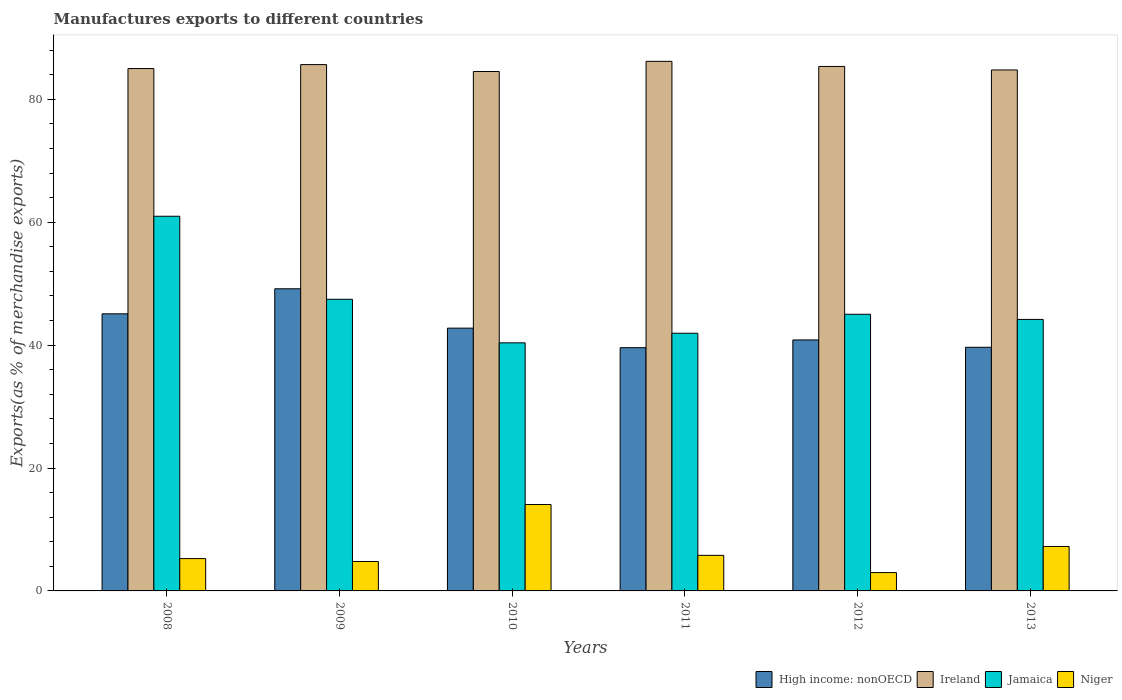How many different coloured bars are there?
Provide a short and direct response. 4. Are the number of bars per tick equal to the number of legend labels?
Give a very brief answer. Yes. Are the number of bars on each tick of the X-axis equal?
Your answer should be compact. Yes. How many bars are there on the 1st tick from the left?
Your answer should be very brief. 4. How many bars are there on the 5th tick from the right?
Your response must be concise. 4. What is the percentage of exports to different countries in Niger in 2012?
Offer a terse response. 2.98. Across all years, what is the maximum percentage of exports to different countries in High income: nonOECD?
Keep it short and to the point. 49.17. Across all years, what is the minimum percentage of exports to different countries in Jamaica?
Your response must be concise. 40.37. What is the total percentage of exports to different countries in High income: nonOECD in the graph?
Your answer should be compact. 257.08. What is the difference between the percentage of exports to different countries in Ireland in 2010 and that in 2013?
Make the answer very short. -0.25. What is the difference between the percentage of exports to different countries in High income: nonOECD in 2010 and the percentage of exports to different countries in Ireland in 2013?
Provide a short and direct response. -42.01. What is the average percentage of exports to different countries in Jamaica per year?
Make the answer very short. 46.65. In the year 2010, what is the difference between the percentage of exports to different countries in Ireland and percentage of exports to different countries in Jamaica?
Make the answer very short. 44.16. What is the ratio of the percentage of exports to different countries in Jamaica in 2011 to that in 2013?
Give a very brief answer. 0.95. Is the percentage of exports to different countries in Jamaica in 2008 less than that in 2009?
Your answer should be very brief. No. What is the difference between the highest and the second highest percentage of exports to different countries in Niger?
Your response must be concise. 6.83. What is the difference between the highest and the lowest percentage of exports to different countries in Niger?
Provide a succinct answer. 11.08. In how many years, is the percentage of exports to different countries in Niger greater than the average percentage of exports to different countries in Niger taken over all years?
Keep it short and to the point. 2. What does the 1st bar from the left in 2011 represents?
Make the answer very short. High income: nonOECD. What does the 3rd bar from the right in 2013 represents?
Your answer should be very brief. Ireland. How many bars are there?
Your answer should be very brief. 24. Are all the bars in the graph horizontal?
Your response must be concise. No. How many years are there in the graph?
Provide a short and direct response. 6. Are the values on the major ticks of Y-axis written in scientific E-notation?
Keep it short and to the point. No. Where does the legend appear in the graph?
Give a very brief answer. Bottom right. How many legend labels are there?
Give a very brief answer. 4. What is the title of the graph?
Your answer should be compact. Manufactures exports to different countries. What is the label or title of the Y-axis?
Provide a short and direct response. Exports(as % of merchandise exports). What is the Exports(as % of merchandise exports) in High income: nonOECD in 2008?
Your answer should be very brief. 45.09. What is the Exports(as % of merchandise exports) in Ireland in 2008?
Provide a short and direct response. 85. What is the Exports(as % of merchandise exports) in Jamaica in 2008?
Offer a very short reply. 60.97. What is the Exports(as % of merchandise exports) in Niger in 2008?
Your response must be concise. 5.26. What is the Exports(as % of merchandise exports) in High income: nonOECD in 2009?
Your response must be concise. 49.17. What is the Exports(as % of merchandise exports) of Ireland in 2009?
Provide a succinct answer. 85.64. What is the Exports(as % of merchandise exports) of Jamaica in 2009?
Ensure brevity in your answer.  47.46. What is the Exports(as % of merchandise exports) of Niger in 2009?
Your response must be concise. 4.79. What is the Exports(as % of merchandise exports) of High income: nonOECD in 2010?
Ensure brevity in your answer.  42.76. What is the Exports(as % of merchandise exports) of Ireland in 2010?
Your answer should be compact. 84.52. What is the Exports(as % of merchandise exports) of Jamaica in 2010?
Your answer should be very brief. 40.37. What is the Exports(as % of merchandise exports) in Niger in 2010?
Provide a short and direct response. 14.06. What is the Exports(as % of merchandise exports) of High income: nonOECD in 2011?
Offer a terse response. 39.58. What is the Exports(as % of merchandise exports) of Ireland in 2011?
Provide a short and direct response. 86.17. What is the Exports(as % of merchandise exports) of Jamaica in 2011?
Offer a very short reply. 41.93. What is the Exports(as % of merchandise exports) of Niger in 2011?
Make the answer very short. 5.79. What is the Exports(as % of merchandise exports) in High income: nonOECD in 2012?
Your answer should be very brief. 40.84. What is the Exports(as % of merchandise exports) in Ireland in 2012?
Offer a terse response. 85.34. What is the Exports(as % of merchandise exports) in Jamaica in 2012?
Offer a terse response. 45.02. What is the Exports(as % of merchandise exports) of Niger in 2012?
Make the answer very short. 2.98. What is the Exports(as % of merchandise exports) in High income: nonOECD in 2013?
Your response must be concise. 39.64. What is the Exports(as % of merchandise exports) in Ireland in 2013?
Your response must be concise. 84.77. What is the Exports(as % of merchandise exports) of Jamaica in 2013?
Keep it short and to the point. 44.18. What is the Exports(as % of merchandise exports) of Niger in 2013?
Keep it short and to the point. 7.23. Across all years, what is the maximum Exports(as % of merchandise exports) in High income: nonOECD?
Your answer should be compact. 49.17. Across all years, what is the maximum Exports(as % of merchandise exports) of Ireland?
Give a very brief answer. 86.17. Across all years, what is the maximum Exports(as % of merchandise exports) in Jamaica?
Keep it short and to the point. 60.97. Across all years, what is the maximum Exports(as % of merchandise exports) of Niger?
Provide a short and direct response. 14.06. Across all years, what is the minimum Exports(as % of merchandise exports) of High income: nonOECD?
Offer a very short reply. 39.58. Across all years, what is the minimum Exports(as % of merchandise exports) in Ireland?
Keep it short and to the point. 84.52. Across all years, what is the minimum Exports(as % of merchandise exports) in Jamaica?
Provide a short and direct response. 40.37. Across all years, what is the minimum Exports(as % of merchandise exports) of Niger?
Provide a succinct answer. 2.98. What is the total Exports(as % of merchandise exports) in High income: nonOECD in the graph?
Keep it short and to the point. 257.08. What is the total Exports(as % of merchandise exports) of Ireland in the graph?
Ensure brevity in your answer.  511.46. What is the total Exports(as % of merchandise exports) of Jamaica in the graph?
Give a very brief answer. 279.92. What is the total Exports(as % of merchandise exports) in Niger in the graph?
Your response must be concise. 40.11. What is the difference between the Exports(as % of merchandise exports) in High income: nonOECD in 2008 and that in 2009?
Your answer should be compact. -4.08. What is the difference between the Exports(as % of merchandise exports) in Ireland in 2008 and that in 2009?
Make the answer very short. -0.64. What is the difference between the Exports(as % of merchandise exports) of Jamaica in 2008 and that in 2009?
Your answer should be very brief. 13.51. What is the difference between the Exports(as % of merchandise exports) in Niger in 2008 and that in 2009?
Ensure brevity in your answer.  0.47. What is the difference between the Exports(as % of merchandise exports) in High income: nonOECD in 2008 and that in 2010?
Give a very brief answer. 2.33. What is the difference between the Exports(as % of merchandise exports) of Ireland in 2008 and that in 2010?
Provide a succinct answer. 0.48. What is the difference between the Exports(as % of merchandise exports) in Jamaica in 2008 and that in 2010?
Ensure brevity in your answer.  20.6. What is the difference between the Exports(as % of merchandise exports) in Niger in 2008 and that in 2010?
Your answer should be very brief. -8.8. What is the difference between the Exports(as % of merchandise exports) in High income: nonOECD in 2008 and that in 2011?
Ensure brevity in your answer.  5.51. What is the difference between the Exports(as % of merchandise exports) in Ireland in 2008 and that in 2011?
Give a very brief answer. -1.17. What is the difference between the Exports(as % of merchandise exports) of Jamaica in 2008 and that in 2011?
Your answer should be very brief. 19.03. What is the difference between the Exports(as % of merchandise exports) in Niger in 2008 and that in 2011?
Give a very brief answer. -0.53. What is the difference between the Exports(as % of merchandise exports) of High income: nonOECD in 2008 and that in 2012?
Ensure brevity in your answer.  4.25. What is the difference between the Exports(as % of merchandise exports) of Ireland in 2008 and that in 2012?
Give a very brief answer. -0.34. What is the difference between the Exports(as % of merchandise exports) in Jamaica in 2008 and that in 2012?
Your answer should be compact. 15.95. What is the difference between the Exports(as % of merchandise exports) in Niger in 2008 and that in 2012?
Your answer should be very brief. 2.28. What is the difference between the Exports(as % of merchandise exports) in High income: nonOECD in 2008 and that in 2013?
Give a very brief answer. 5.45. What is the difference between the Exports(as % of merchandise exports) of Ireland in 2008 and that in 2013?
Make the answer very short. 0.23. What is the difference between the Exports(as % of merchandise exports) of Jamaica in 2008 and that in 2013?
Offer a very short reply. 16.79. What is the difference between the Exports(as % of merchandise exports) of Niger in 2008 and that in 2013?
Provide a succinct answer. -1.97. What is the difference between the Exports(as % of merchandise exports) of High income: nonOECD in 2009 and that in 2010?
Make the answer very short. 6.41. What is the difference between the Exports(as % of merchandise exports) of Ireland in 2009 and that in 2010?
Ensure brevity in your answer.  1.12. What is the difference between the Exports(as % of merchandise exports) in Jamaica in 2009 and that in 2010?
Your answer should be very brief. 7.09. What is the difference between the Exports(as % of merchandise exports) in Niger in 2009 and that in 2010?
Give a very brief answer. -9.27. What is the difference between the Exports(as % of merchandise exports) of High income: nonOECD in 2009 and that in 2011?
Give a very brief answer. 9.59. What is the difference between the Exports(as % of merchandise exports) in Ireland in 2009 and that in 2011?
Make the answer very short. -0.53. What is the difference between the Exports(as % of merchandise exports) of Jamaica in 2009 and that in 2011?
Provide a succinct answer. 5.52. What is the difference between the Exports(as % of merchandise exports) of Niger in 2009 and that in 2011?
Your response must be concise. -1. What is the difference between the Exports(as % of merchandise exports) in High income: nonOECD in 2009 and that in 2012?
Provide a succinct answer. 8.33. What is the difference between the Exports(as % of merchandise exports) of Ireland in 2009 and that in 2012?
Provide a succinct answer. 0.3. What is the difference between the Exports(as % of merchandise exports) of Jamaica in 2009 and that in 2012?
Keep it short and to the point. 2.44. What is the difference between the Exports(as % of merchandise exports) in Niger in 2009 and that in 2012?
Provide a succinct answer. 1.81. What is the difference between the Exports(as % of merchandise exports) of High income: nonOECD in 2009 and that in 2013?
Offer a terse response. 9.52. What is the difference between the Exports(as % of merchandise exports) of Ireland in 2009 and that in 2013?
Your answer should be very brief. 0.87. What is the difference between the Exports(as % of merchandise exports) of Jamaica in 2009 and that in 2013?
Make the answer very short. 3.28. What is the difference between the Exports(as % of merchandise exports) in Niger in 2009 and that in 2013?
Make the answer very short. -2.44. What is the difference between the Exports(as % of merchandise exports) in High income: nonOECD in 2010 and that in 2011?
Give a very brief answer. 3.18. What is the difference between the Exports(as % of merchandise exports) in Ireland in 2010 and that in 2011?
Your answer should be compact. -1.65. What is the difference between the Exports(as % of merchandise exports) of Jamaica in 2010 and that in 2011?
Your answer should be compact. -1.57. What is the difference between the Exports(as % of merchandise exports) of Niger in 2010 and that in 2011?
Keep it short and to the point. 8.27. What is the difference between the Exports(as % of merchandise exports) of High income: nonOECD in 2010 and that in 2012?
Provide a short and direct response. 1.92. What is the difference between the Exports(as % of merchandise exports) of Ireland in 2010 and that in 2012?
Ensure brevity in your answer.  -0.82. What is the difference between the Exports(as % of merchandise exports) in Jamaica in 2010 and that in 2012?
Give a very brief answer. -4.65. What is the difference between the Exports(as % of merchandise exports) in Niger in 2010 and that in 2012?
Give a very brief answer. 11.08. What is the difference between the Exports(as % of merchandise exports) of High income: nonOECD in 2010 and that in 2013?
Provide a succinct answer. 3.12. What is the difference between the Exports(as % of merchandise exports) of Ireland in 2010 and that in 2013?
Your answer should be compact. -0.25. What is the difference between the Exports(as % of merchandise exports) of Jamaica in 2010 and that in 2013?
Give a very brief answer. -3.81. What is the difference between the Exports(as % of merchandise exports) of Niger in 2010 and that in 2013?
Your answer should be very brief. 6.83. What is the difference between the Exports(as % of merchandise exports) in High income: nonOECD in 2011 and that in 2012?
Make the answer very short. -1.26. What is the difference between the Exports(as % of merchandise exports) in Ireland in 2011 and that in 2012?
Your answer should be compact. 0.83. What is the difference between the Exports(as % of merchandise exports) in Jamaica in 2011 and that in 2012?
Your response must be concise. -3.08. What is the difference between the Exports(as % of merchandise exports) in Niger in 2011 and that in 2012?
Offer a very short reply. 2.81. What is the difference between the Exports(as % of merchandise exports) of High income: nonOECD in 2011 and that in 2013?
Ensure brevity in your answer.  -0.06. What is the difference between the Exports(as % of merchandise exports) in Ireland in 2011 and that in 2013?
Give a very brief answer. 1.4. What is the difference between the Exports(as % of merchandise exports) of Jamaica in 2011 and that in 2013?
Your answer should be very brief. -2.25. What is the difference between the Exports(as % of merchandise exports) of Niger in 2011 and that in 2013?
Offer a terse response. -1.44. What is the difference between the Exports(as % of merchandise exports) of High income: nonOECD in 2012 and that in 2013?
Your answer should be compact. 1.19. What is the difference between the Exports(as % of merchandise exports) of Ireland in 2012 and that in 2013?
Provide a succinct answer. 0.57. What is the difference between the Exports(as % of merchandise exports) in Jamaica in 2012 and that in 2013?
Provide a short and direct response. 0.84. What is the difference between the Exports(as % of merchandise exports) of Niger in 2012 and that in 2013?
Provide a succinct answer. -4.25. What is the difference between the Exports(as % of merchandise exports) in High income: nonOECD in 2008 and the Exports(as % of merchandise exports) in Ireland in 2009?
Provide a succinct answer. -40.55. What is the difference between the Exports(as % of merchandise exports) in High income: nonOECD in 2008 and the Exports(as % of merchandise exports) in Jamaica in 2009?
Offer a terse response. -2.37. What is the difference between the Exports(as % of merchandise exports) of High income: nonOECD in 2008 and the Exports(as % of merchandise exports) of Niger in 2009?
Provide a succinct answer. 40.3. What is the difference between the Exports(as % of merchandise exports) in Ireland in 2008 and the Exports(as % of merchandise exports) in Jamaica in 2009?
Keep it short and to the point. 37.54. What is the difference between the Exports(as % of merchandise exports) in Ireland in 2008 and the Exports(as % of merchandise exports) in Niger in 2009?
Offer a terse response. 80.21. What is the difference between the Exports(as % of merchandise exports) in Jamaica in 2008 and the Exports(as % of merchandise exports) in Niger in 2009?
Offer a terse response. 56.18. What is the difference between the Exports(as % of merchandise exports) in High income: nonOECD in 2008 and the Exports(as % of merchandise exports) in Ireland in 2010?
Ensure brevity in your answer.  -39.43. What is the difference between the Exports(as % of merchandise exports) of High income: nonOECD in 2008 and the Exports(as % of merchandise exports) of Jamaica in 2010?
Your response must be concise. 4.72. What is the difference between the Exports(as % of merchandise exports) of High income: nonOECD in 2008 and the Exports(as % of merchandise exports) of Niger in 2010?
Provide a short and direct response. 31.03. What is the difference between the Exports(as % of merchandise exports) in Ireland in 2008 and the Exports(as % of merchandise exports) in Jamaica in 2010?
Offer a very short reply. 44.63. What is the difference between the Exports(as % of merchandise exports) in Ireland in 2008 and the Exports(as % of merchandise exports) in Niger in 2010?
Provide a short and direct response. 70.94. What is the difference between the Exports(as % of merchandise exports) of Jamaica in 2008 and the Exports(as % of merchandise exports) of Niger in 2010?
Give a very brief answer. 46.91. What is the difference between the Exports(as % of merchandise exports) in High income: nonOECD in 2008 and the Exports(as % of merchandise exports) in Ireland in 2011?
Offer a terse response. -41.08. What is the difference between the Exports(as % of merchandise exports) in High income: nonOECD in 2008 and the Exports(as % of merchandise exports) in Jamaica in 2011?
Your answer should be compact. 3.16. What is the difference between the Exports(as % of merchandise exports) of High income: nonOECD in 2008 and the Exports(as % of merchandise exports) of Niger in 2011?
Offer a terse response. 39.3. What is the difference between the Exports(as % of merchandise exports) of Ireland in 2008 and the Exports(as % of merchandise exports) of Jamaica in 2011?
Provide a succinct answer. 43.07. What is the difference between the Exports(as % of merchandise exports) in Ireland in 2008 and the Exports(as % of merchandise exports) in Niger in 2011?
Make the answer very short. 79.21. What is the difference between the Exports(as % of merchandise exports) in Jamaica in 2008 and the Exports(as % of merchandise exports) in Niger in 2011?
Offer a very short reply. 55.18. What is the difference between the Exports(as % of merchandise exports) in High income: nonOECD in 2008 and the Exports(as % of merchandise exports) in Ireland in 2012?
Ensure brevity in your answer.  -40.25. What is the difference between the Exports(as % of merchandise exports) in High income: nonOECD in 2008 and the Exports(as % of merchandise exports) in Jamaica in 2012?
Ensure brevity in your answer.  0.07. What is the difference between the Exports(as % of merchandise exports) in High income: nonOECD in 2008 and the Exports(as % of merchandise exports) in Niger in 2012?
Your response must be concise. 42.11. What is the difference between the Exports(as % of merchandise exports) in Ireland in 2008 and the Exports(as % of merchandise exports) in Jamaica in 2012?
Provide a succinct answer. 39.98. What is the difference between the Exports(as % of merchandise exports) in Ireland in 2008 and the Exports(as % of merchandise exports) in Niger in 2012?
Your answer should be very brief. 82.02. What is the difference between the Exports(as % of merchandise exports) of Jamaica in 2008 and the Exports(as % of merchandise exports) of Niger in 2012?
Offer a terse response. 57.98. What is the difference between the Exports(as % of merchandise exports) in High income: nonOECD in 2008 and the Exports(as % of merchandise exports) in Ireland in 2013?
Ensure brevity in your answer.  -39.68. What is the difference between the Exports(as % of merchandise exports) of High income: nonOECD in 2008 and the Exports(as % of merchandise exports) of Jamaica in 2013?
Give a very brief answer. 0.91. What is the difference between the Exports(as % of merchandise exports) of High income: nonOECD in 2008 and the Exports(as % of merchandise exports) of Niger in 2013?
Give a very brief answer. 37.86. What is the difference between the Exports(as % of merchandise exports) in Ireland in 2008 and the Exports(as % of merchandise exports) in Jamaica in 2013?
Your answer should be very brief. 40.82. What is the difference between the Exports(as % of merchandise exports) in Ireland in 2008 and the Exports(as % of merchandise exports) in Niger in 2013?
Make the answer very short. 77.77. What is the difference between the Exports(as % of merchandise exports) of Jamaica in 2008 and the Exports(as % of merchandise exports) of Niger in 2013?
Offer a very short reply. 53.74. What is the difference between the Exports(as % of merchandise exports) in High income: nonOECD in 2009 and the Exports(as % of merchandise exports) in Ireland in 2010?
Ensure brevity in your answer.  -35.36. What is the difference between the Exports(as % of merchandise exports) of High income: nonOECD in 2009 and the Exports(as % of merchandise exports) of Jamaica in 2010?
Ensure brevity in your answer.  8.8. What is the difference between the Exports(as % of merchandise exports) of High income: nonOECD in 2009 and the Exports(as % of merchandise exports) of Niger in 2010?
Provide a succinct answer. 35.11. What is the difference between the Exports(as % of merchandise exports) in Ireland in 2009 and the Exports(as % of merchandise exports) in Jamaica in 2010?
Offer a terse response. 45.28. What is the difference between the Exports(as % of merchandise exports) of Ireland in 2009 and the Exports(as % of merchandise exports) of Niger in 2010?
Offer a terse response. 71.58. What is the difference between the Exports(as % of merchandise exports) in Jamaica in 2009 and the Exports(as % of merchandise exports) in Niger in 2010?
Provide a succinct answer. 33.4. What is the difference between the Exports(as % of merchandise exports) in High income: nonOECD in 2009 and the Exports(as % of merchandise exports) in Ireland in 2011?
Provide a succinct answer. -37.01. What is the difference between the Exports(as % of merchandise exports) in High income: nonOECD in 2009 and the Exports(as % of merchandise exports) in Jamaica in 2011?
Ensure brevity in your answer.  7.23. What is the difference between the Exports(as % of merchandise exports) in High income: nonOECD in 2009 and the Exports(as % of merchandise exports) in Niger in 2011?
Give a very brief answer. 43.38. What is the difference between the Exports(as % of merchandise exports) in Ireland in 2009 and the Exports(as % of merchandise exports) in Jamaica in 2011?
Make the answer very short. 43.71. What is the difference between the Exports(as % of merchandise exports) in Ireland in 2009 and the Exports(as % of merchandise exports) in Niger in 2011?
Offer a terse response. 79.86. What is the difference between the Exports(as % of merchandise exports) in Jamaica in 2009 and the Exports(as % of merchandise exports) in Niger in 2011?
Ensure brevity in your answer.  41.67. What is the difference between the Exports(as % of merchandise exports) of High income: nonOECD in 2009 and the Exports(as % of merchandise exports) of Ireland in 2012?
Offer a very short reply. -36.18. What is the difference between the Exports(as % of merchandise exports) in High income: nonOECD in 2009 and the Exports(as % of merchandise exports) in Jamaica in 2012?
Ensure brevity in your answer.  4.15. What is the difference between the Exports(as % of merchandise exports) in High income: nonOECD in 2009 and the Exports(as % of merchandise exports) in Niger in 2012?
Your response must be concise. 46.18. What is the difference between the Exports(as % of merchandise exports) of Ireland in 2009 and the Exports(as % of merchandise exports) of Jamaica in 2012?
Offer a very short reply. 40.63. What is the difference between the Exports(as % of merchandise exports) in Ireland in 2009 and the Exports(as % of merchandise exports) in Niger in 2012?
Your response must be concise. 82.66. What is the difference between the Exports(as % of merchandise exports) of Jamaica in 2009 and the Exports(as % of merchandise exports) of Niger in 2012?
Give a very brief answer. 44.48. What is the difference between the Exports(as % of merchandise exports) of High income: nonOECD in 2009 and the Exports(as % of merchandise exports) of Ireland in 2013?
Provide a succinct answer. -35.61. What is the difference between the Exports(as % of merchandise exports) in High income: nonOECD in 2009 and the Exports(as % of merchandise exports) in Jamaica in 2013?
Offer a terse response. 4.99. What is the difference between the Exports(as % of merchandise exports) of High income: nonOECD in 2009 and the Exports(as % of merchandise exports) of Niger in 2013?
Make the answer very short. 41.94. What is the difference between the Exports(as % of merchandise exports) in Ireland in 2009 and the Exports(as % of merchandise exports) in Jamaica in 2013?
Ensure brevity in your answer.  41.46. What is the difference between the Exports(as % of merchandise exports) in Ireland in 2009 and the Exports(as % of merchandise exports) in Niger in 2013?
Provide a succinct answer. 78.41. What is the difference between the Exports(as % of merchandise exports) of Jamaica in 2009 and the Exports(as % of merchandise exports) of Niger in 2013?
Give a very brief answer. 40.23. What is the difference between the Exports(as % of merchandise exports) of High income: nonOECD in 2010 and the Exports(as % of merchandise exports) of Ireland in 2011?
Offer a very short reply. -43.41. What is the difference between the Exports(as % of merchandise exports) in High income: nonOECD in 2010 and the Exports(as % of merchandise exports) in Jamaica in 2011?
Offer a very short reply. 0.83. What is the difference between the Exports(as % of merchandise exports) of High income: nonOECD in 2010 and the Exports(as % of merchandise exports) of Niger in 2011?
Provide a succinct answer. 36.97. What is the difference between the Exports(as % of merchandise exports) of Ireland in 2010 and the Exports(as % of merchandise exports) of Jamaica in 2011?
Your response must be concise. 42.59. What is the difference between the Exports(as % of merchandise exports) of Ireland in 2010 and the Exports(as % of merchandise exports) of Niger in 2011?
Ensure brevity in your answer.  78.73. What is the difference between the Exports(as % of merchandise exports) of Jamaica in 2010 and the Exports(as % of merchandise exports) of Niger in 2011?
Make the answer very short. 34.58. What is the difference between the Exports(as % of merchandise exports) in High income: nonOECD in 2010 and the Exports(as % of merchandise exports) in Ireland in 2012?
Offer a terse response. -42.58. What is the difference between the Exports(as % of merchandise exports) of High income: nonOECD in 2010 and the Exports(as % of merchandise exports) of Jamaica in 2012?
Ensure brevity in your answer.  -2.26. What is the difference between the Exports(as % of merchandise exports) in High income: nonOECD in 2010 and the Exports(as % of merchandise exports) in Niger in 2012?
Keep it short and to the point. 39.78. What is the difference between the Exports(as % of merchandise exports) of Ireland in 2010 and the Exports(as % of merchandise exports) of Jamaica in 2012?
Your answer should be very brief. 39.51. What is the difference between the Exports(as % of merchandise exports) of Ireland in 2010 and the Exports(as % of merchandise exports) of Niger in 2012?
Provide a short and direct response. 81.54. What is the difference between the Exports(as % of merchandise exports) in Jamaica in 2010 and the Exports(as % of merchandise exports) in Niger in 2012?
Your answer should be compact. 37.38. What is the difference between the Exports(as % of merchandise exports) of High income: nonOECD in 2010 and the Exports(as % of merchandise exports) of Ireland in 2013?
Your answer should be very brief. -42.01. What is the difference between the Exports(as % of merchandise exports) in High income: nonOECD in 2010 and the Exports(as % of merchandise exports) in Jamaica in 2013?
Give a very brief answer. -1.42. What is the difference between the Exports(as % of merchandise exports) of High income: nonOECD in 2010 and the Exports(as % of merchandise exports) of Niger in 2013?
Give a very brief answer. 35.53. What is the difference between the Exports(as % of merchandise exports) of Ireland in 2010 and the Exports(as % of merchandise exports) of Jamaica in 2013?
Offer a very short reply. 40.34. What is the difference between the Exports(as % of merchandise exports) in Ireland in 2010 and the Exports(as % of merchandise exports) in Niger in 2013?
Ensure brevity in your answer.  77.29. What is the difference between the Exports(as % of merchandise exports) in Jamaica in 2010 and the Exports(as % of merchandise exports) in Niger in 2013?
Make the answer very short. 33.14. What is the difference between the Exports(as % of merchandise exports) in High income: nonOECD in 2011 and the Exports(as % of merchandise exports) in Ireland in 2012?
Your answer should be compact. -45.76. What is the difference between the Exports(as % of merchandise exports) in High income: nonOECD in 2011 and the Exports(as % of merchandise exports) in Jamaica in 2012?
Offer a very short reply. -5.44. What is the difference between the Exports(as % of merchandise exports) in High income: nonOECD in 2011 and the Exports(as % of merchandise exports) in Niger in 2012?
Provide a succinct answer. 36.6. What is the difference between the Exports(as % of merchandise exports) of Ireland in 2011 and the Exports(as % of merchandise exports) of Jamaica in 2012?
Provide a short and direct response. 41.15. What is the difference between the Exports(as % of merchandise exports) of Ireland in 2011 and the Exports(as % of merchandise exports) of Niger in 2012?
Provide a succinct answer. 83.19. What is the difference between the Exports(as % of merchandise exports) in Jamaica in 2011 and the Exports(as % of merchandise exports) in Niger in 2012?
Ensure brevity in your answer.  38.95. What is the difference between the Exports(as % of merchandise exports) of High income: nonOECD in 2011 and the Exports(as % of merchandise exports) of Ireland in 2013?
Offer a very short reply. -45.19. What is the difference between the Exports(as % of merchandise exports) in High income: nonOECD in 2011 and the Exports(as % of merchandise exports) in Jamaica in 2013?
Offer a terse response. -4.6. What is the difference between the Exports(as % of merchandise exports) in High income: nonOECD in 2011 and the Exports(as % of merchandise exports) in Niger in 2013?
Provide a succinct answer. 32.35. What is the difference between the Exports(as % of merchandise exports) of Ireland in 2011 and the Exports(as % of merchandise exports) of Jamaica in 2013?
Provide a succinct answer. 41.99. What is the difference between the Exports(as % of merchandise exports) of Ireland in 2011 and the Exports(as % of merchandise exports) of Niger in 2013?
Your answer should be very brief. 78.94. What is the difference between the Exports(as % of merchandise exports) of Jamaica in 2011 and the Exports(as % of merchandise exports) of Niger in 2013?
Offer a terse response. 34.7. What is the difference between the Exports(as % of merchandise exports) in High income: nonOECD in 2012 and the Exports(as % of merchandise exports) in Ireland in 2013?
Provide a succinct answer. -43.94. What is the difference between the Exports(as % of merchandise exports) of High income: nonOECD in 2012 and the Exports(as % of merchandise exports) of Jamaica in 2013?
Provide a succinct answer. -3.34. What is the difference between the Exports(as % of merchandise exports) in High income: nonOECD in 2012 and the Exports(as % of merchandise exports) in Niger in 2013?
Your answer should be compact. 33.61. What is the difference between the Exports(as % of merchandise exports) of Ireland in 2012 and the Exports(as % of merchandise exports) of Jamaica in 2013?
Offer a very short reply. 41.17. What is the difference between the Exports(as % of merchandise exports) in Ireland in 2012 and the Exports(as % of merchandise exports) in Niger in 2013?
Ensure brevity in your answer.  78.11. What is the difference between the Exports(as % of merchandise exports) in Jamaica in 2012 and the Exports(as % of merchandise exports) in Niger in 2013?
Offer a very short reply. 37.79. What is the average Exports(as % of merchandise exports) in High income: nonOECD per year?
Offer a very short reply. 42.85. What is the average Exports(as % of merchandise exports) of Ireland per year?
Offer a terse response. 85.24. What is the average Exports(as % of merchandise exports) in Jamaica per year?
Keep it short and to the point. 46.65. What is the average Exports(as % of merchandise exports) of Niger per year?
Make the answer very short. 6.69. In the year 2008, what is the difference between the Exports(as % of merchandise exports) in High income: nonOECD and Exports(as % of merchandise exports) in Ireland?
Offer a terse response. -39.91. In the year 2008, what is the difference between the Exports(as % of merchandise exports) of High income: nonOECD and Exports(as % of merchandise exports) of Jamaica?
Offer a terse response. -15.88. In the year 2008, what is the difference between the Exports(as % of merchandise exports) in High income: nonOECD and Exports(as % of merchandise exports) in Niger?
Offer a very short reply. 39.83. In the year 2008, what is the difference between the Exports(as % of merchandise exports) in Ireland and Exports(as % of merchandise exports) in Jamaica?
Your response must be concise. 24.03. In the year 2008, what is the difference between the Exports(as % of merchandise exports) of Ireland and Exports(as % of merchandise exports) of Niger?
Provide a short and direct response. 79.74. In the year 2008, what is the difference between the Exports(as % of merchandise exports) in Jamaica and Exports(as % of merchandise exports) in Niger?
Offer a terse response. 55.7. In the year 2009, what is the difference between the Exports(as % of merchandise exports) of High income: nonOECD and Exports(as % of merchandise exports) of Ireland?
Make the answer very short. -36.48. In the year 2009, what is the difference between the Exports(as % of merchandise exports) of High income: nonOECD and Exports(as % of merchandise exports) of Jamaica?
Your answer should be compact. 1.71. In the year 2009, what is the difference between the Exports(as % of merchandise exports) of High income: nonOECD and Exports(as % of merchandise exports) of Niger?
Make the answer very short. 44.38. In the year 2009, what is the difference between the Exports(as % of merchandise exports) in Ireland and Exports(as % of merchandise exports) in Jamaica?
Make the answer very short. 38.19. In the year 2009, what is the difference between the Exports(as % of merchandise exports) of Ireland and Exports(as % of merchandise exports) of Niger?
Make the answer very short. 80.85. In the year 2009, what is the difference between the Exports(as % of merchandise exports) in Jamaica and Exports(as % of merchandise exports) in Niger?
Provide a succinct answer. 42.67. In the year 2010, what is the difference between the Exports(as % of merchandise exports) of High income: nonOECD and Exports(as % of merchandise exports) of Ireland?
Make the answer very short. -41.76. In the year 2010, what is the difference between the Exports(as % of merchandise exports) in High income: nonOECD and Exports(as % of merchandise exports) in Jamaica?
Make the answer very short. 2.39. In the year 2010, what is the difference between the Exports(as % of merchandise exports) of High income: nonOECD and Exports(as % of merchandise exports) of Niger?
Offer a terse response. 28.7. In the year 2010, what is the difference between the Exports(as % of merchandise exports) in Ireland and Exports(as % of merchandise exports) in Jamaica?
Provide a succinct answer. 44.16. In the year 2010, what is the difference between the Exports(as % of merchandise exports) of Ireland and Exports(as % of merchandise exports) of Niger?
Keep it short and to the point. 70.46. In the year 2010, what is the difference between the Exports(as % of merchandise exports) of Jamaica and Exports(as % of merchandise exports) of Niger?
Offer a very short reply. 26.31. In the year 2011, what is the difference between the Exports(as % of merchandise exports) in High income: nonOECD and Exports(as % of merchandise exports) in Ireland?
Provide a short and direct response. -46.59. In the year 2011, what is the difference between the Exports(as % of merchandise exports) in High income: nonOECD and Exports(as % of merchandise exports) in Jamaica?
Your response must be concise. -2.35. In the year 2011, what is the difference between the Exports(as % of merchandise exports) of High income: nonOECD and Exports(as % of merchandise exports) of Niger?
Offer a very short reply. 33.79. In the year 2011, what is the difference between the Exports(as % of merchandise exports) of Ireland and Exports(as % of merchandise exports) of Jamaica?
Offer a very short reply. 44.24. In the year 2011, what is the difference between the Exports(as % of merchandise exports) in Ireland and Exports(as % of merchandise exports) in Niger?
Your answer should be very brief. 80.38. In the year 2011, what is the difference between the Exports(as % of merchandise exports) of Jamaica and Exports(as % of merchandise exports) of Niger?
Make the answer very short. 36.15. In the year 2012, what is the difference between the Exports(as % of merchandise exports) of High income: nonOECD and Exports(as % of merchandise exports) of Ireland?
Give a very brief answer. -44.51. In the year 2012, what is the difference between the Exports(as % of merchandise exports) in High income: nonOECD and Exports(as % of merchandise exports) in Jamaica?
Provide a succinct answer. -4.18. In the year 2012, what is the difference between the Exports(as % of merchandise exports) in High income: nonOECD and Exports(as % of merchandise exports) in Niger?
Provide a short and direct response. 37.86. In the year 2012, what is the difference between the Exports(as % of merchandise exports) of Ireland and Exports(as % of merchandise exports) of Jamaica?
Offer a terse response. 40.33. In the year 2012, what is the difference between the Exports(as % of merchandise exports) in Ireland and Exports(as % of merchandise exports) in Niger?
Your answer should be compact. 82.36. In the year 2012, what is the difference between the Exports(as % of merchandise exports) of Jamaica and Exports(as % of merchandise exports) of Niger?
Ensure brevity in your answer.  42.03. In the year 2013, what is the difference between the Exports(as % of merchandise exports) in High income: nonOECD and Exports(as % of merchandise exports) in Ireland?
Offer a very short reply. -45.13. In the year 2013, what is the difference between the Exports(as % of merchandise exports) of High income: nonOECD and Exports(as % of merchandise exports) of Jamaica?
Your answer should be very brief. -4.54. In the year 2013, what is the difference between the Exports(as % of merchandise exports) in High income: nonOECD and Exports(as % of merchandise exports) in Niger?
Offer a very short reply. 32.41. In the year 2013, what is the difference between the Exports(as % of merchandise exports) in Ireland and Exports(as % of merchandise exports) in Jamaica?
Provide a short and direct response. 40.6. In the year 2013, what is the difference between the Exports(as % of merchandise exports) of Ireland and Exports(as % of merchandise exports) of Niger?
Keep it short and to the point. 77.54. In the year 2013, what is the difference between the Exports(as % of merchandise exports) of Jamaica and Exports(as % of merchandise exports) of Niger?
Your answer should be very brief. 36.95. What is the ratio of the Exports(as % of merchandise exports) in High income: nonOECD in 2008 to that in 2009?
Provide a succinct answer. 0.92. What is the ratio of the Exports(as % of merchandise exports) in Ireland in 2008 to that in 2009?
Your answer should be very brief. 0.99. What is the ratio of the Exports(as % of merchandise exports) of Jamaica in 2008 to that in 2009?
Provide a short and direct response. 1.28. What is the ratio of the Exports(as % of merchandise exports) in Niger in 2008 to that in 2009?
Your answer should be compact. 1.1. What is the ratio of the Exports(as % of merchandise exports) of High income: nonOECD in 2008 to that in 2010?
Ensure brevity in your answer.  1.05. What is the ratio of the Exports(as % of merchandise exports) of Ireland in 2008 to that in 2010?
Offer a terse response. 1.01. What is the ratio of the Exports(as % of merchandise exports) of Jamaica in 2008 to that in 2010?
Make the answer very short. 1.51. What is the ratio of the Exports(as % of merchandise exports) in Niger in 2008 to that in 2010?
Ensure brevity in your answer.  0.37. What is the ratio of the Exports(as % of merchandise exports) in High income: nonOECD in 2008 to that in 2011?
Your answer should be compact. 1.14. What is the ratio of the Exports(as % of merchandise exports) in Ireland in 2008 to that in 2011?
Provide a succinct answer. 0.99. What is the ratio of the Exports(as % of merchandise exports) in Jamaica in 2008 to that in 2011?
Provide a succinct answer. 1.45. What is the ratio of the Exports(as % of merchandise exports) of Niger in 2008 to that in 2011?
Offer a very short reply. 0.91. What is the ratio of the Exports(as % of merchandise exports) of High income: nonOECD in 2008 to that in 2012?
Keep it short and to the point. 1.1. What is the ratio of the Exports(as % of merchandise exports) of Jamaica in 2008 to that in 2012?
Your response must be concise. 1.35. What is the ratio of the Exports(as % of merchandise exports) in Niger in 2008 to that in 2012?
Provide a short and direct response. 1.76. What is the ratio of the Exports(as % of merchandise exports) in High income: nonOECD in 2008 to that in 2013?
Your response must be concise. 1.14. What is the ratio of the Exports(as % of merchandise exports) in Ireland in 2008 to that in 2013?
Your response must be concise. 1. What is the ratio of the Exports(as % of merchandise exports) of Jamaica in 2008 to that in 2013?
Give a very brief answer. 1.38. What is the ratio of the Exports(as % of merchandise exports) in Niger in 2008 to that in 2013?
Ensure brevity in your answer.  0.73. What is the ratio of the Exports(as % of merchandise exports) of High income: nonOECD in 2009 to that in 2010?
Offer a terse response. 1.15. What is the ratio of the Exports(as % of merchandise exports) in Ireland in 2009 to that in 2010?
Make the answer very short. 1.01. What is the ratio of the Exports(as % of merchandise exports) in Jamaica in 2009 to that in 2010?
Ensure brevity in your answer.  1.18. What is the ratio of the Exports(as % of merchandise exports) of Niger in 2009 to that in 2010?
Make the answer very short. 0.34. What is the ratio of the Exports(as % of merchandise exports) in High income: nonOECD in 2009 to that in 2011?
Keep it short and to the point. 1.24. What is the ratio of the Exports(as % of merchandise exports) of Jamaica in 2009 to that in 2011?
Keep it short and to the point. 1.13. What is the ratio of the Exports(as % of merchandise exports) in Niger in 2009 to that in 2011?
Offer a terse response. 0.83. What is the ratio of the Exports(as % of merchandise exports) of High income: nonOECD in 2009 to that in 2012?
Offer a terse response. 1.2. What is the ratio of the Exports(as % of merchandise exports) in Ireland in 2009 to that in 2012?
Provide a succinct answer. 1. What is the ratio of the Exports(as % of merchandise exports) of Jamaica in 2009 to that in 2012?
Your response must be concise. 1.05. What is the ratio of the Exports(as % of merchandise exports) in Niger in 2009 to that in 2012?
Offer a terse response. 1.61. What is the ratio of the Exports(as % of merchandise exports) of High income: nonOECD in 2009 to that in 2013?
Provide a succinct answer. 1.24. What is the ratio of the Exports(as % of merchandise exports) of Ireland in 2009 to that in 2013?
Your response must be concise. 1.01. What is the ratio of the Exports(as % of merchandise exports) in Jamaica in 2009 to that in 2013?
Keep it short and to the point. 1.07. What is the ratio of the Exports(as % of merchandise exports) in Niger in 2009 to that in 2013?
Offer a terse response. 0.66. What is the ratio of the Exports(as % of merchandise exports) in High income: nonOECD in 2010 to that in 2011?
Ensure brevity in your answer.  1.08. What is the ratio of the Exports(as % of merchandise exports) of Ireland in 2010 to that in 2011?
Keep it short and to the point. 0.98. What is the ratio of the Exports(as % of merchandise exports) of Jamaica in 2010 to that in 2011?
Your response must be concise. 0.96. What is the ratio of the Exports(as % of merchandise exports) in Niger in 2010 to that in 2011?
Offer a very short reply. 2.43. What is the ratio of the Exports(as % of merchandise exports) of High income: nonOECD in 2010 to that in 2012?
Your answer should be compact. 1.05. What is the ratio of the Exports(as % of merchandise exports) in Jamaica in 2010 to that in 2012?
Your response must be concise. 0.9. What is the ratio of the Exports(as % of merchandise exports) of Niger in 2010 to that in 2012?
Provide a succinct answer. 4.71. What is the ratio of the Exports(as % of merchandise exports) in High income: nonOECD in 2010 to that in 2013?
Provide a short and direct response. 1.08. What is the ratio of the Exports(as % of merchandise exports) of Ireland in 2010 to that in 2013?
Offer a terse response. 1. What is the ratio of the Exports(as % of merchandise exports) of Jamaica in 2010 to that in 2013?
Provide a short and direct response. 0.91. What is the ratio of the Exports(as % of merchandise exports) of Niger in 2010 to that in 2013?
Your answer should be compact. 1.94. What is the ratio of the Exports(as % of merchandise exports) of High income: nonOECD in 2011 to that in 2012?
Your response must be concise. 0.97. What is the ratio of the Exports(as % of merchandise exports) of Ireland in 2011 to that in 2012?
Make the answer very short. 1.01. What is the ratio of the Exports(as % of merchandise exports) of Jamaica in 2011 to that in 2012?
Give a very brief answer. 0.93. What is the ratio of the Exports(as % of merchandise exports) of Niger in 2011 to that in 2012?
Provide a short and direct response. 1.94. What is the ratio of the Exports(as % of merchandise exports) of Ireland in 2011 to that in 2013?
Offer a terse response. 1.02. What is the ratio of the Exports(as % of merchandise exports) in Jamaica in 2011 to that in 2013?
Ensure brevity in your answer.  0.95. What is the ratio of the Exports(as % of merchandise exports) in Niger in 2011 to that in 2013?
Your answer should be very brief. 0.8. What is the ratio of the Exports(as % of merchandise exports) of High income: nonOECD in 2012 to that in 2013?
Offer a very short reply. 1.03. What is the ratio of the Exports(as % of merchandise exports) in Jamaica in 2012 to that in 2013?
Your answer should be very brief. 1.02. What is the ratio of the Exports(as % of merchandise exports) of Niger in 2012 to that in 2013?
Provide a short and direct response. 0.41. What is the difference between the highest and the second highest Exports(as % of merchandise exports) of High income: nonOECD?
Provide a succinct answer. 4.08. What is the difference between the highest and the second highest Exports(as % of merchandise exports) in Ireland?
Your response must be concise. 0.53. What is the difference between the highest and the second highest Exports(as % of merchandise exports) of Jamaica?
Provide a succinct answer. 13.51. What is the difference between the highest and the second highest Exports(as % of merchandise exports) of Niger?
Your answer should be compact. 6.83. What is the difference between the highest and the lowest Exports(as % of merchandise exports) in High income: nonOECD?
Provide a succinct answer. 9.59. What is the difference between the highest and the lowest Exports(as % of merchandise exports) in Ireland?
Your response must be concise. 1.65. What is the difference between the highest and the lowest Exports(as % of merchandise exports) in Jamaica?
Offer a terse response. 20.6. What is the difference between the highest and the lowest Exports(as % of merchandise exports) of Niger?
Make the answer very short. 11.08. 